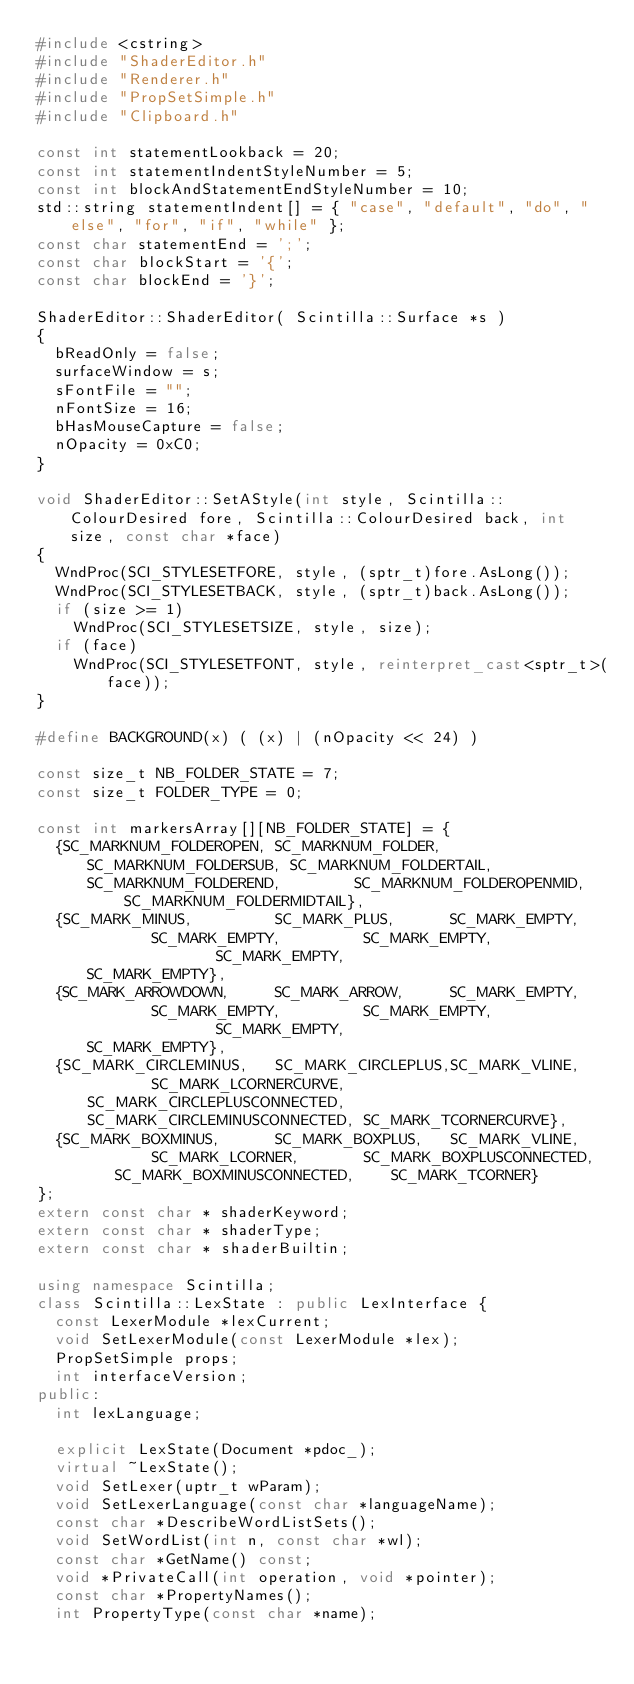<code> <loc_0><loc_0><loc_500><loc_500><_C++_>#include <cstring>
#include "ShaderEditor.h"
#include "Renderer.h"
#include "PropSetSimple.h"
#include "Clipboard.h"

const int statementLookback = 20;
const int statementIndentStyleNumber = 5;
const int blockAndStatementEndStyleNumber = 10;
std::string statementIndent[] = { "case", "default", "do", "else", "for", "if", "while" };
const char statementEnd = ';';
const char blockStart = '{';
const char blockEnd = '}';

ShaderEditor::ShaderEditor( Scintilla::Surface *s )
{
  bReadOnly = false;
  surfaceWindow = s;
  sFontFile = "";
  nFontSize = 16;
  bHasMouseCapture = false;
  nOpacity = 0xC0;
}

void ShaderEditor::SetAStyle(int style, Scintilla::ColourDesired fore, Scintilla::ColourDesired back, int size, const char *face)
{
  WndProc(SCI_STYLESETFORE, style, (sptr_t)fore.AsLong());
  WndProc(SCI_STYLESETBACK, style, (sptr_t)back.AsLong());
  if (size >= 1)
    WndProc(SCI_STYLESETSIZE, style, size);
  if (face) 
    WndProc(SCI_STYLESETFONT, style, reinterpret_cast<sptr_t>(face));
}

#define BACKGROUND(x) ( (x) | (nOpacity << 24) )

const size_t NB_FOLDER_STATE = 7;
const size_t FOLDER_TYPE = 0;

const int markersArray[][NB_FOLDER_STATE] = {
  {SC_MARKNUM_FOLDEROPEN, SC_MARKNUM_FOLDER, SC_MARKNUM_FOLDERSUB, SC_MARKNUM_FOLDERTAIL, SC_MARKNUM_FOLDEREND,        SC_MARKNUM_FOLDEROPENMID,     SC_MARKNUM_FOLDERMIDTAIL},
  {SC_MARK_MINUS,         SC_MARK_PLUS,      SC_MARK_EMPTY,        SC_MARK_EMPTY,         SC_MARK_EMPTY,               SC_MARK_EMPTY,                SC_MARK_EMPTY},
  {SC_MARK_ARROWDOWN,     SC_MARK_ARROW,     SC_MARK_EMPTY,        SC_MARK_EMPTY,         SC_MARK_EMPTY,               SC_MARK_EMPTY,                SC_MARK_EMPTY},
  {SC_MARK_CIRCLEMINUS,   SC_MARK_CIRCLEPLUS,SC_MARK_VLINE,        SC_MARK_LCORNERCURVE,  SC_MARK_CIRCLEPLUSCONNECTED, SC_MARK_CIRCLEMINUSCONNECTED, SC_MARK_TCORNERCURVE},
  {SC_MARK_BOXMINUS,      SC_MARK_BOXPLUS,   SC_MARK_VLINE,        SC_MARK_LCORNER,       SC_MARK_BOXPLUSCONNECTED,    SC_MARK_BOXMINUSCONNECTED,    SC_MARK_TCORNER}
};
extern const char * shaderKeyword;
extern const char * shaderType;
extern const char * shaderBuiltin;

using namespace Scintilla;
class Scintilla::LexState : public LexInterface {
  const LexerModule *lexCurrent;
  void SetLexerModule(const LexerModule *lex);
  PropSetSimple props;
  int interfaceVersion;
public:
  int lexLanguage;

  explicit LexState(Document *pdoc_);
  virtual ~LexState();
  void SetLexer(uptr_t wParam);
  void SetLexerLanguage(const char *languageName);
  const char *DescribeWordListSets();
  void SetWordList(int n, const char *wl);
  const char *GetName() const;
  void *PrivateCall(int operation, void *pointer);
  const char *PropertyNames();
  int PropertyType(const char *name);</code> 